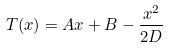Convert formula to latex. <formula><loc_0><loc_0><loc_500><loc_500>T ( x ) = A x + B - \frac { x ^ { 2 } } { 2 D }</formula> 